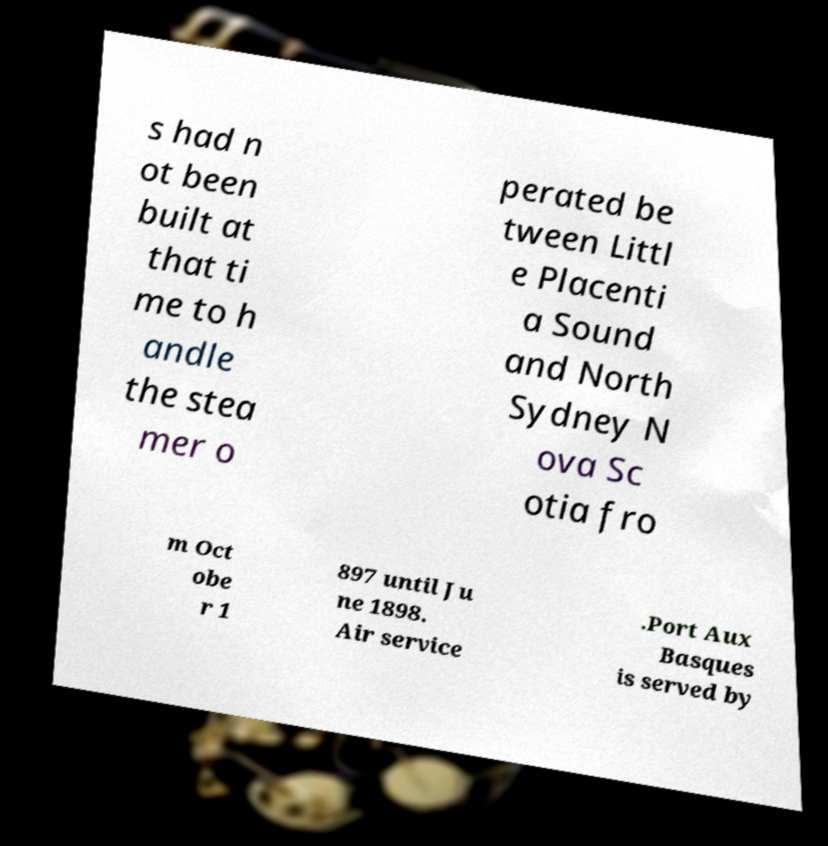For documentation purposes, I need the text within this image transcribed. Could you provide that? s had n ot been built at that ti me to h andle the stea mer o perated be tween Littl e Placenti a Sound and North Sydney N ova Sc otia fro m Oct obe r 1 897 until Ju ne 1898. Air service .Port Aux Basques is served by 